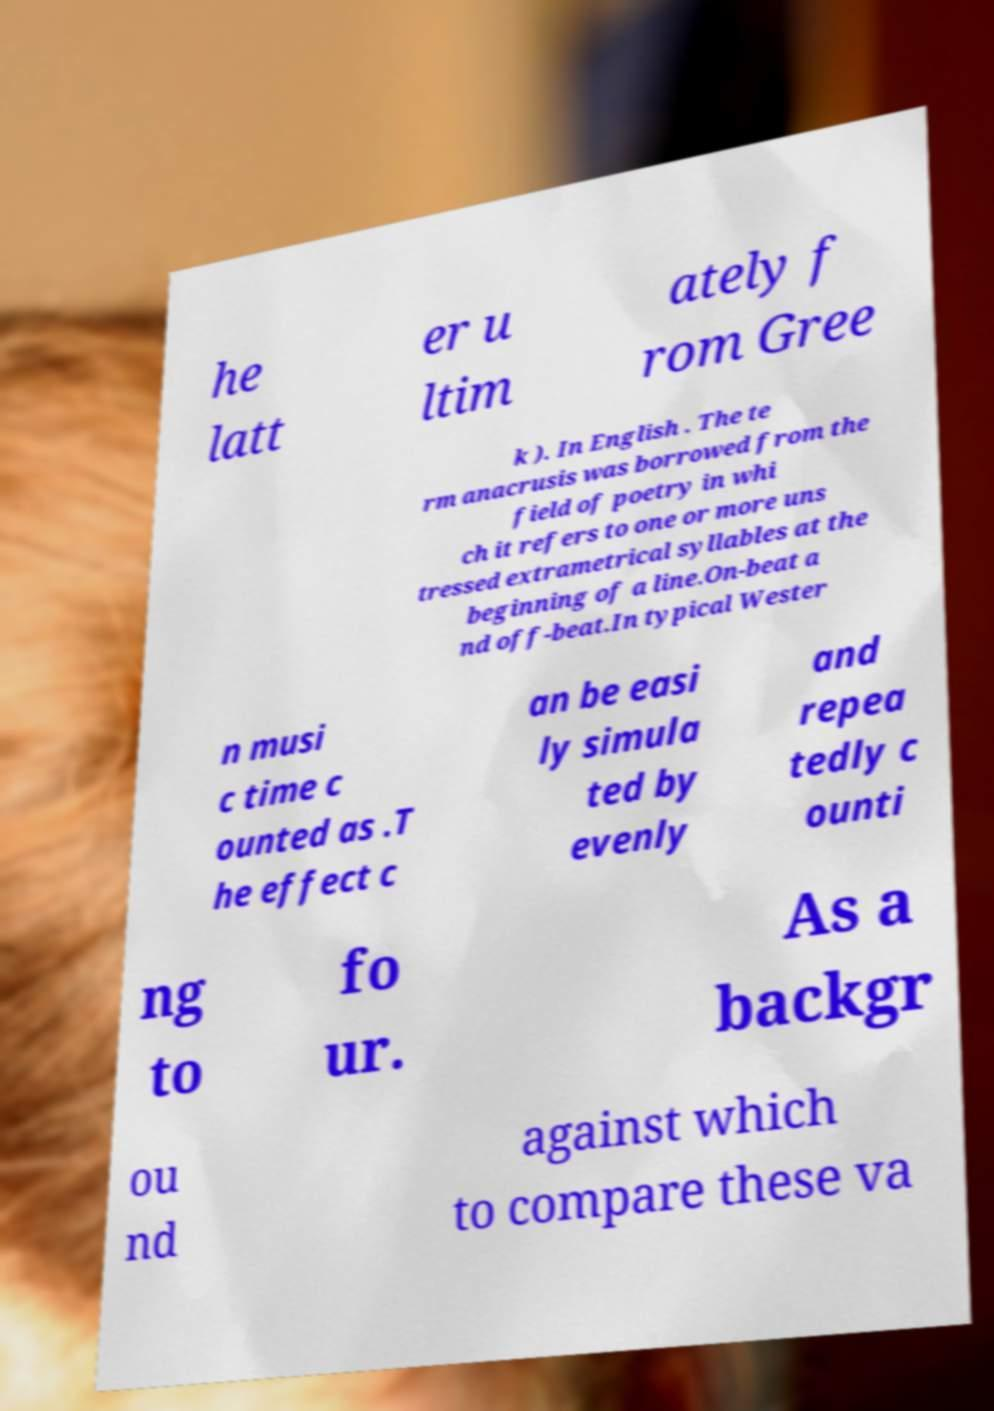Could you assist in decoding the text presented in this image and type it out clearly? he latt er u ltim ately f rom Gree k ). In English . The te rm anacrusis was borrowed from the field of poetry in whi ch it refers to one or more uns tressed extrametrical syllables at the beginning of a line.On-beat a nd off-beat.In typical Wester n musi c time c ounted as .T he effect c an be easi ly simula ted by evenly and repea tedly c ounti ng to fo ur. As a backgr ou nd against which to compare these va 